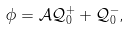Convert formula to latex. <formula><loc_0><loc_0><loc_500><loc_500>\phi = \mathcal { A } \mathcal { Q } ^ { + } _ { 0 } + \mathcal { Q } ^ { - } _ { 0 } ,</formula> 